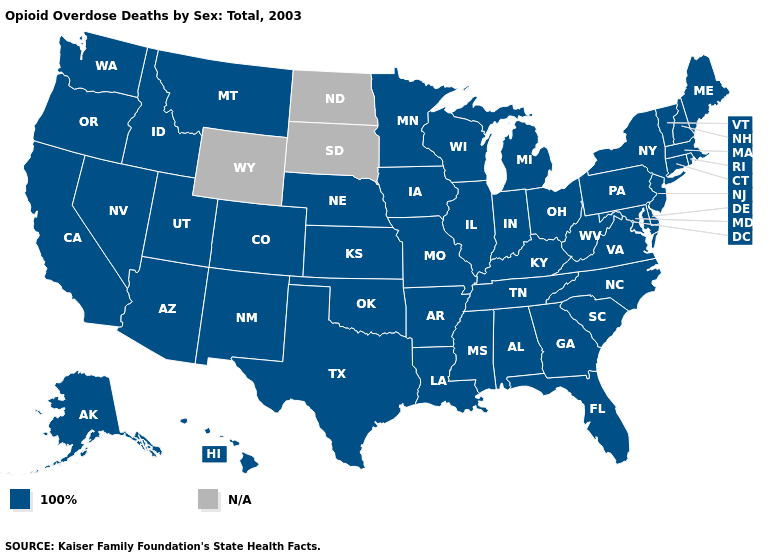What is the value of South Carolina?
Keep it brief. 100%. Does the first symbol in the legend represent the smallest category?
Give a very brief answer. Yes. What is the value of South Carolina?
Write a very short answer. 100%. Name the states that have a value in the range N/A?
Answer briefly. North Dakota, South Dakota, Wyoming. What is the lowest value in the West?
Short answer required. 100%. What is the value of Maryland?
Give a very brief answer. 100%. Which states have the lowest value in the USA?
Give a very brief answer. Alabama, Alaska, Arizona, Arkansas, California, Colorado, Connecticut, Delaware, Florida, Georgia, Hawaii, Idaho, Illinois, Indiana, Iowa, Kansas, Kentucky, Louisiana, Maine, Maryland, Massachusetts, Michigan, Minnesota, Mississippi, Missouri, Montana, Nebraska, Nevada, New Hampshire, New Jersey, New Mexico, New York, North Carolina, Ohio, Oklahoma, Oregon, Pennsylvania, Rhode Island, South Carolina, Tennessee, Texas, Utah, Vermont, Virginia, Washington, West Virginia, Wisconsin. 